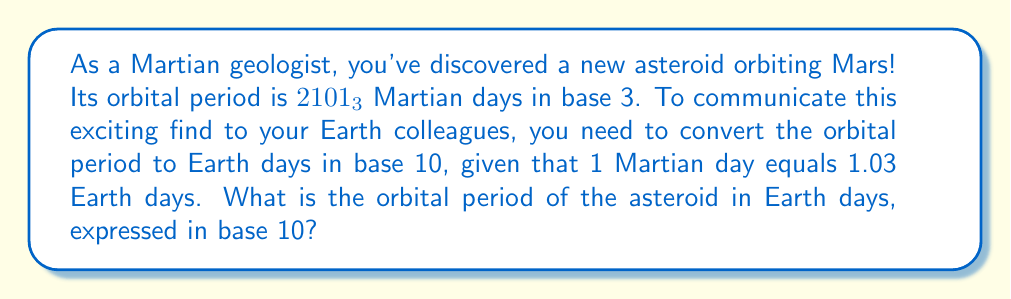Can you solve this math problem? Let's approach this problem step-by-step:

1) First, we need to convert $2101_3$ from base 3 to base 10.

   In base 3, each digit represents a power of 3:

   $$2101_3 = 2 \times 3^3 + 1 \times 3^2 + 0 \times 3^1 + 1 \times 3^0$$

   $$= 2 \times 27 + 1 \times 9 + 0 \times 3 + 1 \times 1$$
   
   $$= 54 + 9 + 0 + 1$$
   
   $$= 64_{10}$$

2) So, the orbital period is 64 Martian days.

3) Now, we need to convert Martian days to Earth days:

   $$64 \times 1.03 = 65.92$$

Therefore, the orbital period of the asteroid is 65.92 Earth days.
Answer: 65.92 Earth days 